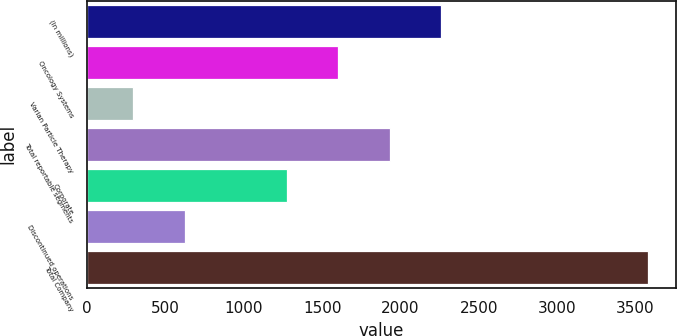Convert chart to OTSL. <chart><loc_0><loc_0><loc_500><loc_500><bar_chart><fcel>(In millions)<fcel>Oncology Systems<fcel>Varian Particle Therapy<fcel>Total reportable segments<fcel>Corporate<fcel>Discontinued operations<fcel>Total Company<nl><fcel>2261.31<fcel>1604.37<fcel>294<fcel>1932.84<fcel>1275.9<fcel>622.47<fcel>3578.7<nl></chart> 